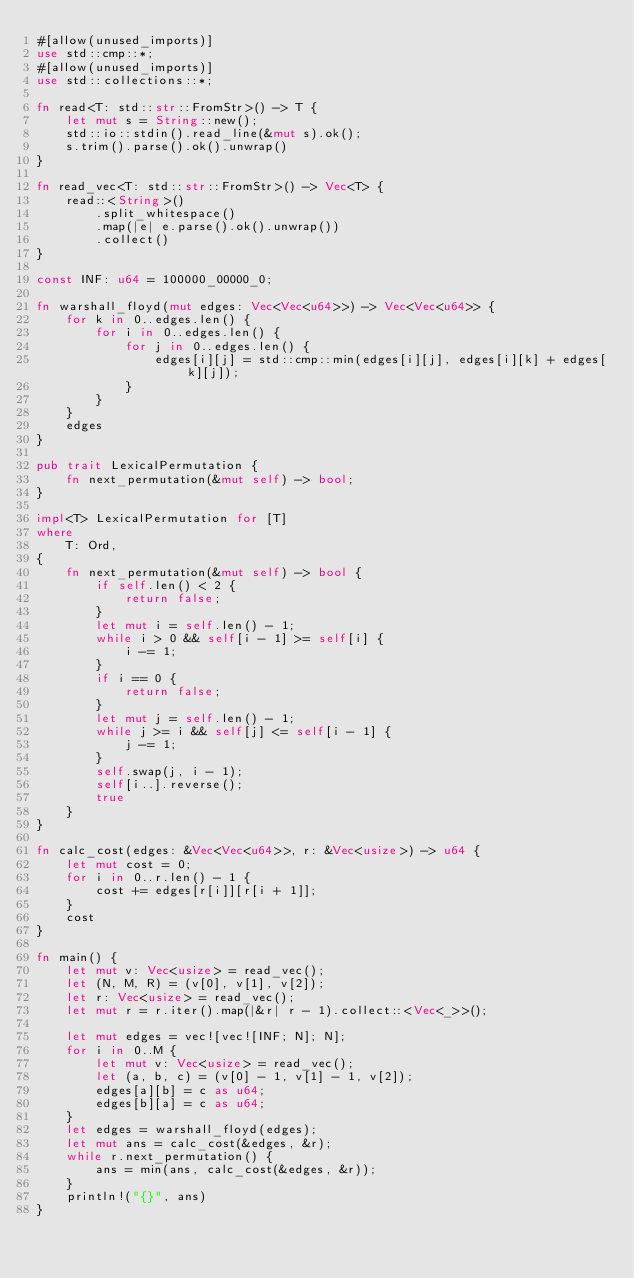Convert code to text. <code><loc_0><loc_0><loc_500><loc_500><_Rust_>#[allow(unused_imports)]
use std::cmp::*;
#[allow(unused_imports)]
use std::collections::*;

fn read<T: std::str::FromStr>() -> T {
    let mut s = String::new();
    std::io::stdin().read_line(&mut s).ok();
    s.trim().parse().ok().unwrap()
}

fn read_vec<T: std::str::FromStr>() -> Vec<T> {
    read::<String>()
        .split_whitespace()
        .map(|e| e.parse().ok().unwrap())
        .collect()
}

const INF: u64 = 100000_00000_0;

fn warshall_floyd(mut edges: Vec<Vec<u64>>) -> Vec<Vec<u64>> {
    for k in 0..edges.len() {
        for i in 0..edges.len() {
            for j in 0..edges.len() {
                edges[i][j] = std::cmp::min(edges[i][j], edges[i][k] + edges[k][j]);
            }
        }
    }
    edges
}

pub trait LexicalPermutation {
    fn next_permutation(&mut self) -> bool;
}

impl<T> LexicalPermutation for [T]
where
    T: Ord,
{
    fn next_permutation(&mut self) -> bool {
        if self.len() < 2 {
            return false;
        }
        let mut i = self.len() - 1;
        while i > 0 && self[i - 1] >= self[i] {
            i -= 1;
        }
        if i == 0 {
            return false;
        }
        let mut j = self.len() - 1;
        while j >= i && self[j] <= self[i - 1] {
            j -= 1;
        }
        self.swap(j, i - 1);
        self[i..].reverse();
        true
    }
}

fn calc_cost(edges: &Vec<Vec<u64>>, r: &Vec<usize>) -> u64 {
    let mut cost = 0;
    for i in 0..r.len() - 1 {
        cost += edges[r[i]][r[i + 1]];
    }
    cost
}

fn main() {
    let mut v: Vec<usize> = read_vec();
    let (N, M, R) = (v[0], v[1], v[2]);
    let r: Vec<usize> = read_vec();
    let mut r = r.iter().map(|&r| r - 1).collect::<Vec<_>>();

    let mut edges = vec![vec![INF; N]; N];
    for i in 0..M {
        let mut v: Vec<usize> = read_vec();
        let (a, b, c) = (v[0] - 1, v[1] - 1, v[2]);
        edges[a][b] = c as u64;
        edges[b][a] = c as u64;
    }
    let edges = warshall_floyd(edges);
    let mut ans = calc_cost(&edges, &r);
    while r.next_permutation() {
        ans = min(ans, calc_cost(&edges, &r));
    }
    println!("{}", ans)
}
</code> 